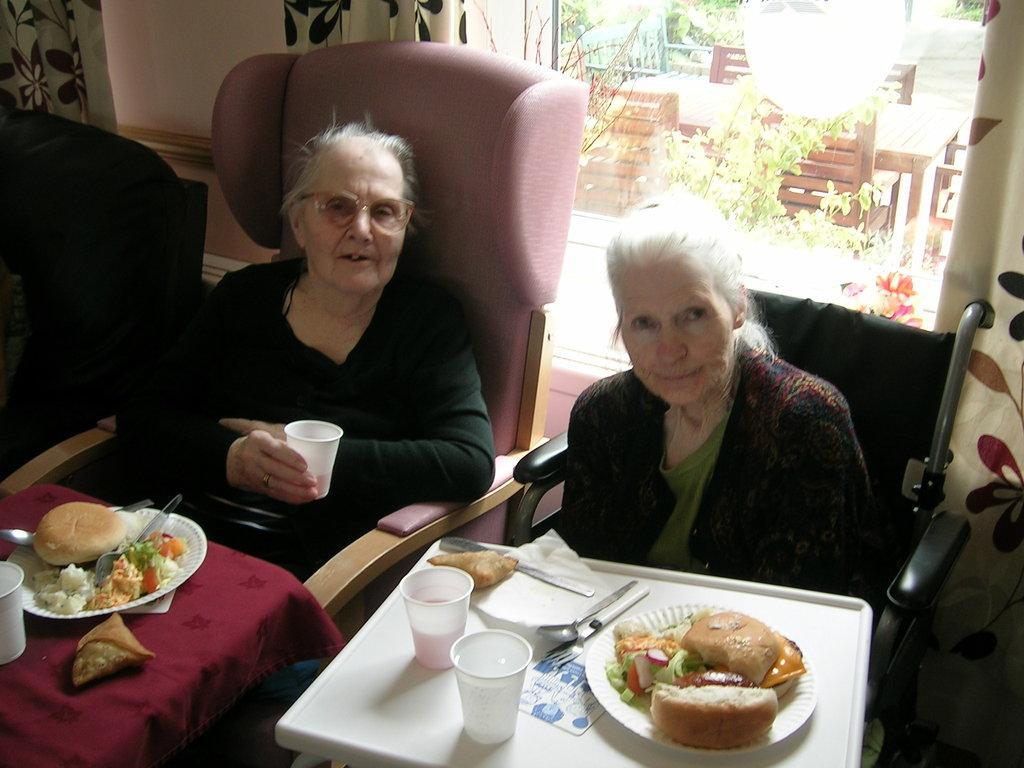Could you give a brief overview of what you see in this image? Here we can see two women are sitting on the chairs. These are the tables. On the table there are glasses, plates, and food. She is holding a glass with her hand and she has spectacles. On the background there is a window. From the window we can see planets and this is wall. 